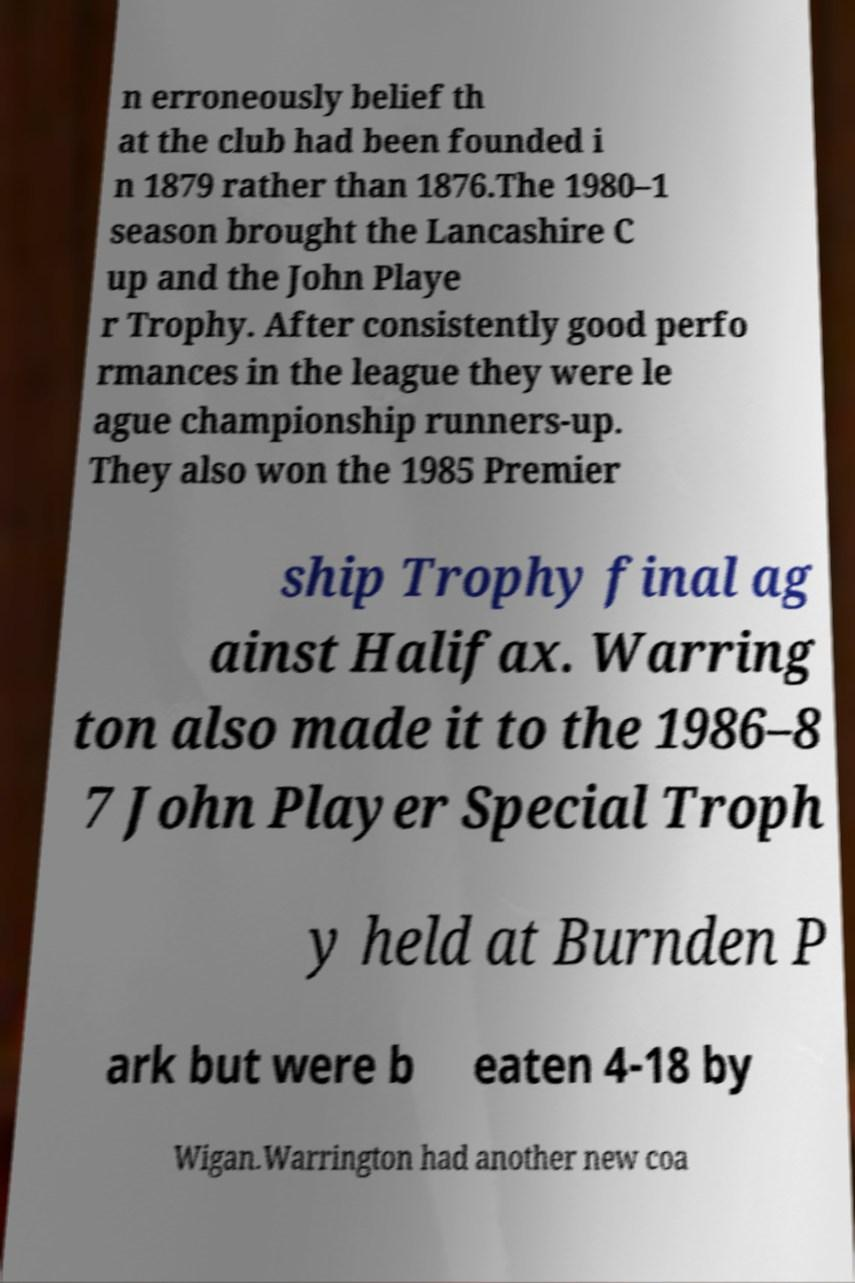There's text embedded in this image that I need extracted. Can you transcribe it verbatim? n erroneously belief th at the club had been founded i n 1879 rather than 1876.The 1980–1 season brought the Lancashire C up and the John Playe r Trophy. After consistently good perfo rmances in the league they were le ague championship runners-up. They also won the 1985 Premier ship Trophy final ag ainst Halifax. Warring ton also made it to the 1986–8 7 John Player Special Troph y held at Burnden P ark but were b eaten 4-18 by Wigan.Warrington had another new coa 